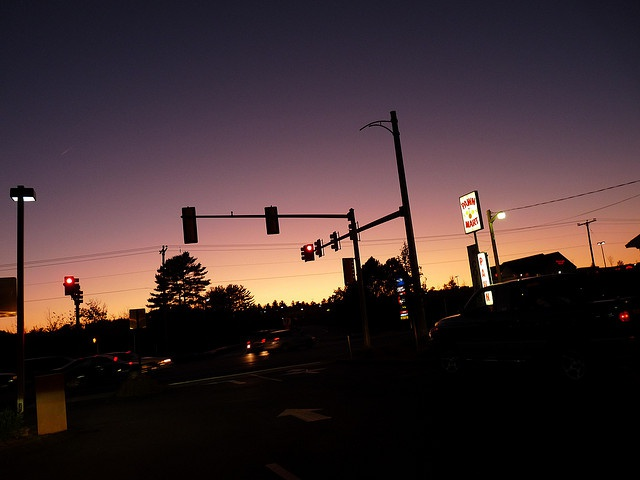Describe the objects in this image and their specific colors. I can see car in black, maroon, darkgreen, and olive tones, car in black, maroon, and red tones, car in black, maroon, and brown tones, car in black, maroon, brown, and red tones, and traffic light in black, gray, lightpink, and brown tones in this image. 